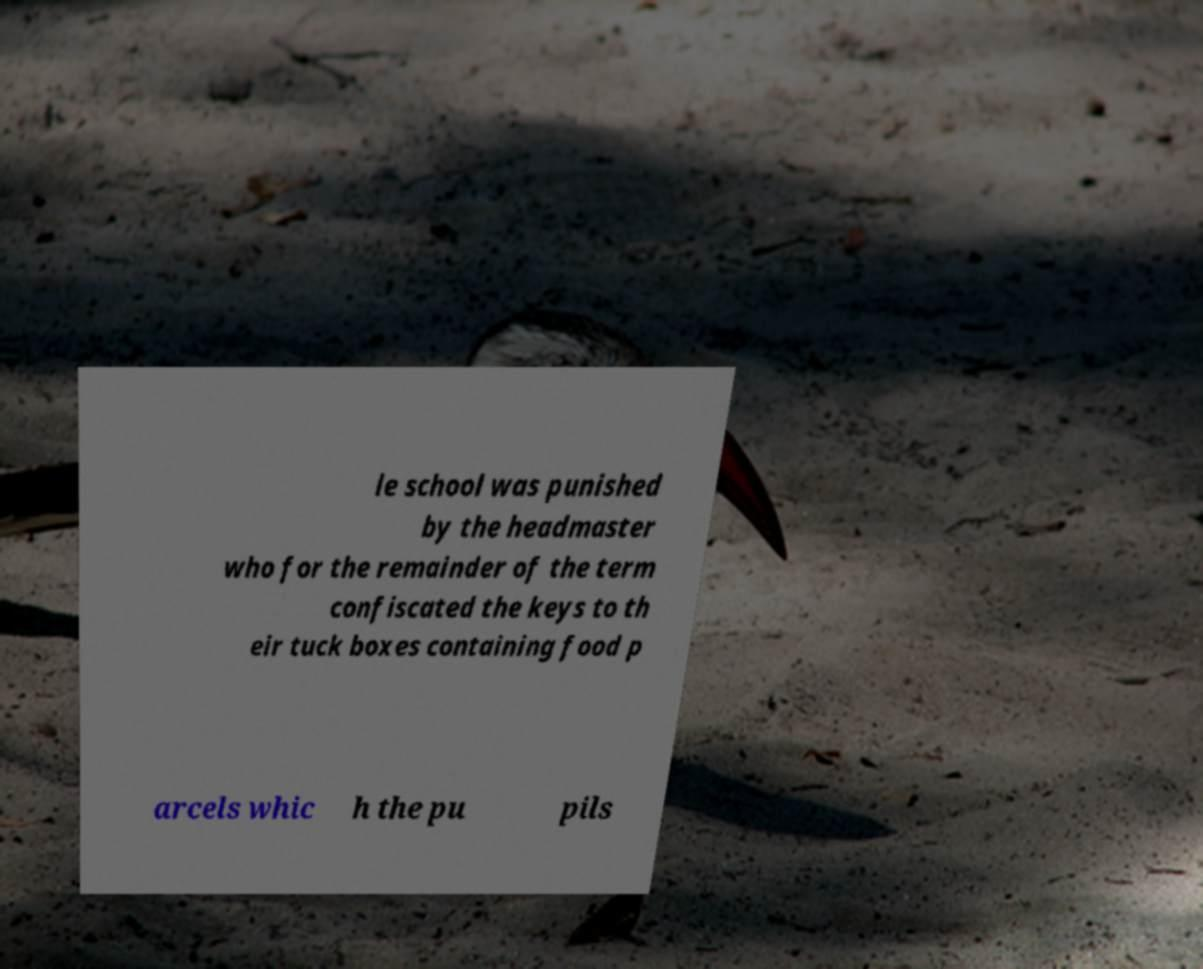What messages or text are displayed in this image? I need them in a readable, typed format. le school was punished by the headmaster who for the remainder of the term confiscated the keys to th eir tuck boxes containing food p arcels whic h the pu pils 